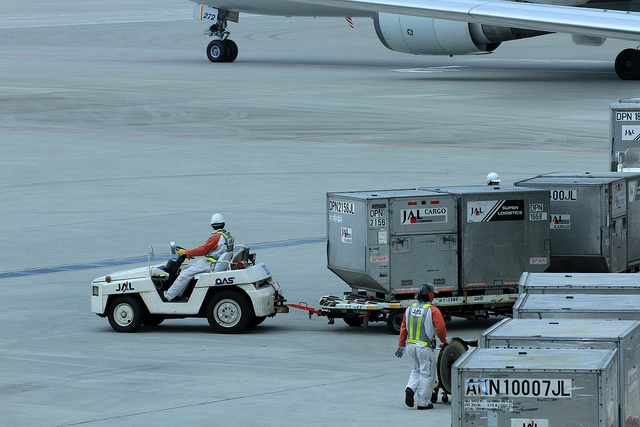Describe the objects in this image and their specific colors. I can see airplane in darkgray, gray, lightblue, and black tones, car in darkgray, black, gray, and lightblue tones, truck in darkgray, black, gray, and lightblue tones, truck in darkgray, black, and gray tones, and people in darkgray, gray, and black tones in this image. 